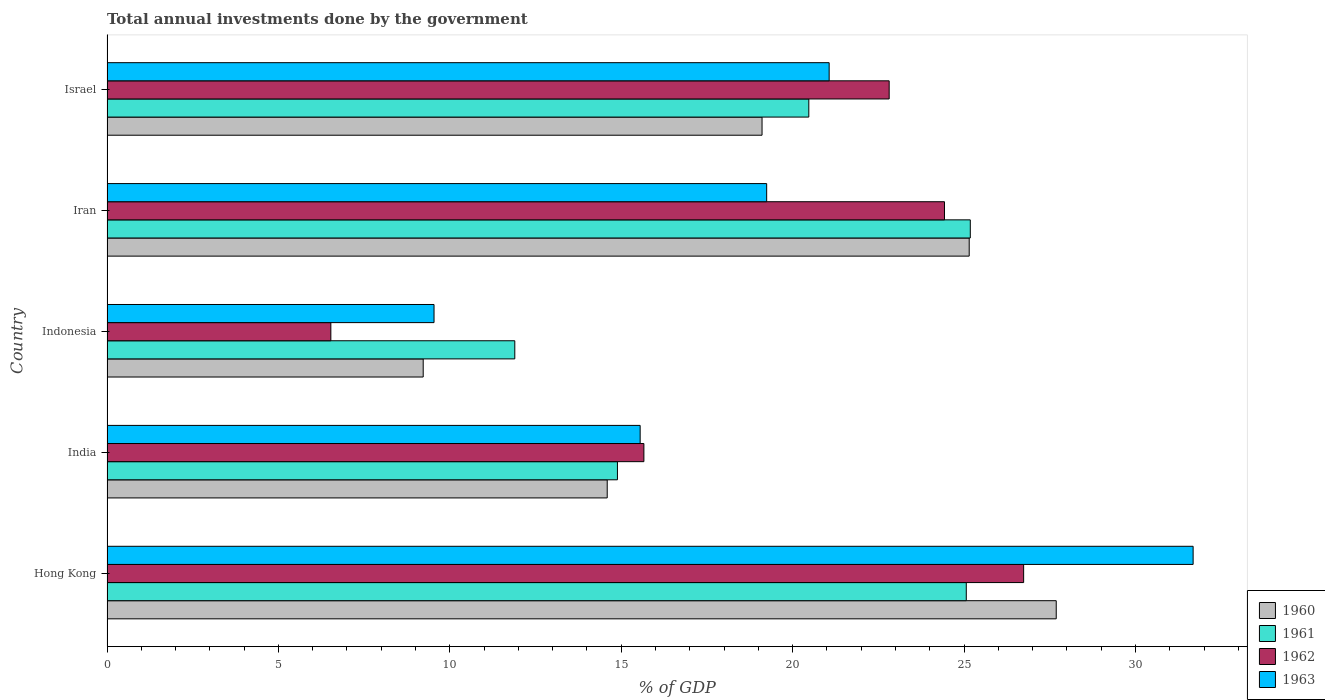How many different coloured bars are there?
Ensure brevity in your answer.  4. Are the number of bars per tick equal to the number of legend labels?
Ensure brevity in your answer.  Yes. How many bars are there on the 1st tick from the top?
Provide a short and direct response. 4. What is the label of the 1st group of bars from the top?
Offer a very short reply. Israel. What is the total annual investments done by the government in 1960 in India?
Offer a very short reply. 14.59. Across all countries, what is the maximum total annual investments done by the government in 1961?
Ensure brevity in your answer.  25.18. Across all countries, what is the minimum total annual investments done by the government in 1963?
Offer a very short reply. 9.54. In which country was the total annual investments done by the government in 1962 maximum?
Give a very brief answer. Hong Kong. What is the total total annual investments done by the government in 1960 in the graph?
Keep it short and to the point. 95.76. What is the difference between the total annual investments done by the government in 1963 in Indonesia and that in Iran?
Make the answer very short. -9.7. What is the difference between the total annual investments done by the government in 1960 in India and the total annual investments done by the government in 1963 in Iran?
Offer a very short reply. -4.65. What is the average total annual investments done by the government in 1960 per country?
Ensure brevity in your answer.  19.15. What is the difference between the total annual investments done by the government in 1962 and total annual investments done by the government in 1960 in India?
Give a very brief answer. 1.07. What is the ratio of the total annual investments done by the government in 1963 in Hong Kong to that in Iran?
Offer a terse response. 1.65. Is the total annual investments done by the government in 1961 in India less than that in Indonesia?
Provide a succinct answer. No. What is the difference between the highest and the second highest total annual investments done by the government in 1963?
Offer a terse response. 10.62. What is the difference between the highest and the lowest total annual investments done by the government in 1963?
Offer a very short reply. 22.14. In how many countries, is the total annual investments done by the government in 1960 greater than the average total annual investments done by the government in 1960 taken over all countries?
Ensure brevity in your answer.  2. Is it the case that in every country, the sum of the total annual investments done by the government in 1963 and total annual investments done by the government in 1960 is greater than the sum of total annual investments done by the government in 1961 and total annual investments done by the government in 1962?
Offer a very short reply. No. What does the 1st bar from the top in Indonesia represents?
Offer a terse response. 1963. What does the 2nd bar from the bottom in Indonesia represents?
Offer a very short reply. 1961. Is it the case that in every country, the sum of the total annual investments done by the government in 1960 and total annual investments done by the government in 1963 is greater than the total annual investments done by the government in 1962?
Keep it short and to the point. Yes. How many countries are there in the graph?
Ensure brevity in your answer.  5. What is the difference between two consecutive major ticks on the X-axis?
Provide a succinct answer. 5. Does the graph contain any zero values?
Give a very brief answer. No. Where does the legend appear in the graph?
Give a very brief answer. Bottom right. How are the legend labels stacked?
Ensure brevity in your answer.  Vertical. What is the title of the graph?
Your answer should be compact. Total annual investments done by the government. Does "2005" appear as one of the legend labels in the graph?
Offer a very short reply. No. What is the label or title of the X-axis?
Keep it short and to the point. % of GDP. What is the label or title of the Y-axis?
Make the answer very short. Country. What is the % of GDP of 1960 in Hong Kong?
Your answer should be compact. 27.69. What is the % of GDP in 1961 in Hong Kong?
Give a very brief answer. 25.06. What is the % of GDP in 1962 in Hong Kong?
Make the answer very short. 26.74. What is the % of GDP of 1963 in Hong Kong?
Your response must be concise. 31.68. What is the % of GDP of 1960 in India?
Offer a very short reply. 14.59. What is the % of GDP of 1961 in India?
Give a very brief answer. 14.89. What is the % of GDP of 1962 in India?
Keep it short and to the point. 15.66. What is the % of GDP in 1963 in India?
Make the answer very short. 15.55. What is the % of GDP of 1960 in Indonesia?
Provide a short and direct response. 9.22. What is the % of GDP in 1961 in Indonesia?
Ensure brevity in your answer.  11.9. What is the % of GDP in 1962 in Indonesia?
Keep it short and to the point. 6.53. What is the % of GDP of 1963 in Indonesia?
Provide a short and direct response. 9.54. What is the % of GDP in 1960 in Iran?
Your response must be concise. 25.15. What is the % of GDP of 1961 in Iran?
Provide a short and direct response. 25.18. What is the % of GDP of 1962 in Iran?
Provide a succinct answer. 24.43. What is the % of GDP in 1963 in Iran?
Offer a terse response. 19.24. What is the % of GDP in 1960 in Israel?
Keep it short and to the point. 19.11. What is the % of GDP in 1961 in Israel?
Give a very brief answer. 20.47. What is the % of GDP in 1962 in Israel?
Ensure brevity in your answer.  22.82. What is the % of GDP in 1963 in Israel?
Ensure brevity in your answer.  21.06. Across all countries, what is the maximum % of GDP of 1960?
Provide a succinct answer. 27.69. Across all countries, what is the maximum % of GDP in 1961?
Ensure brevity in your answer.  25.18. Across all countries, what is the maximum % of GDP of 1962?
Your response must be concise. 26.74. Across all countries, what is the maximum % of GDP in 1963?
Provide a succinct answer. 31.68. Across all countries, what is the minimum % of GDP in 1960?
Provide a short and direct response. 9.22. Across all countries, what is the minimum % of GDP in 1961?
Your answer should be very brief. 11.9. Across all countries, what is the minimum % of GDP in 1962?
Ensure brevity in your answer.  6.53. Across all countries, what is the minimum % of GDP in 1963?
Your response must be concise. 9.54. What is the total % of GDP of 1960 in the graph?
Offer a terse response. 95.76. What is the total % of GDP in 1961 in the graph?
Provide a short and direct response. 97.5. What is the total % of GDP in 1962 in the graph?
Ensure brevity in your answer.  96.17. What is the total % of GDP in 1963 in the graph?
Offer a terse response. 97.08. What is the difference between the % of GDP of 1960 in Hong Kong and that in India?
Make the answer very short. 13.1. What is the difference between the % of GDP of 1961 in Hong Kong and that in India?
Your response must be concise. 10.18. What is the difference between the % of GDP of 1962 in Hong Kong and that in India?
Your response must be concise. 11.08. What is the difference between the % of GDP of 1963 in Hong Kong and that in India?
Your answer should be very brief. 16.13. What is the difference between the % of GDP of 1960 in Hong Kong and that in Indonesia?
Give a very brief answer. 18.47. What is the difference between the % of GDP in 1961 in Hong Kong and that in Indonesia?
Your response must be concise. 13.17. What is the difference between the % of GDP of 1962 in Hong Kong and that in Indonesia?
Offer a very short reply. 20.21. What is the difference between the % of GDP of 1963 in Hong Kong and that in Indonesia?
Your answer should be very brief. 22.14. What is the difference between the % of GDP in 1960 in Hong Kong and that in Iran?
Offer a very short reply. 2.54. What is the difference between the % of GDP in 1961 in Hong Kong and that in Iran?
Keep it short and to the point. -0.12. What is the difference between the % of GDP in 1962 in Hong Kong and that in Iran?
Keep it short and to the point. 2.31. What is the difference between the % of GDP in 1963 in Hong Kong and that in Iran?
Your answer should be very brief. 12.44. What is the difference between the % of GDP in 1960 in Hong Kong and that in Israel?
Provide a succinct answer. 8.58. What is the difference between the % of GDP in 1961 in Hong Kong and that in Israel?
Keep it short and to the point. 4.59. What is the difference between the % of GDP in 1962 in Hong Kong and that in Israel?
Provide a short and direct response. 3.92. What is the difference between the % of GDP of 1963 in Hong Kong and that in Israel?
Offer a terse response. 10.62. What is the difference between the % of GDP of 1960 in India and that in Indonesia?
Your answer should be very brief. 5.37. What is the difference between the % of GDP in 1961 in India and that in Indonesia?
Keep it short and to the point. 2.99. What is the difference between the % of GDP of 1962 in India and that in Indonesia?
Provide a short and direct response. 9.13. What is the difference between the % of GDP in 1963 in India and that in Indonesia?
Offer a very short reply. 6.01. What is the difference between the % of GDP in 1960 in India and that in Iran?
Your answer should be compact. -10.56. What is the difference between the % of GDP of 1961 in India and that in Iran?
Provide a short and direct response. -10.29. What is the difference between the % of GDP of 1962 in India and that in Iran?
Provide a short and direct response. -8.77. What is the difference between the % of GDP in 1963 in India and that in Iran?
Provide a short and direct response. -3.69. What is the difference between the % of GDP in 1960 in India and that in Israel?
Make the answer very short. -4.52. What is the difference between the % of GDP in 1961 in India and that in Israel?
Ensure brevity in your answer.  -5.58. What is the difference between the % of GDP in 1962 in India and that in Israel?
Offer a very short reply. -7.15. What is the difference between the % of GDP in 1963 in India and that in Israel?
Give a very brief answer. -5.51. What is the difference between the % of GDP in 1960 in Indonesia and that in Iran?
Provide a succinct answer. -15.93. What is the difference between the % of GDP in 1961 in Indonesia and that in Iran?
Make the answer very short. -13.29. What is the difference between the % of GDP of 1962 in Indonesia and that in Iran?
Make the answer very short. -17.9. What is the difference between the % of GDP of 1963 in Indonesia and that in Iran?
Your answer should be compact. -9.7. What is the difference between the % of GDP in 1960 in Indonesia and that in Israel?
Provide a short and direct response. -9.88. What is the difference between the % of GDP of 1961 in Indonesia and that in Israel?
Your answer should be compact. -8.58. What is the difference between the % of GDP in 1962 in Indonesia and that in Israel?
Make the answer very short. -16.29. What is the difference between the % of GDP of 1963 in Indonesia and that in Israel?
Offer a terse response. -11.53. What is the difference between the % of GDP in 1960 in Iran and that in Israel?
Your response must be concise. 6.04. What is the difference between the % of GDP in 1961 in Iran and that in Israel?
Give a very brief answer. 4.71. What is the difference between the % of GDP in 1962 in Iran and that in Israel?
Keep it short and to the point. 1.61. What is the difference between the % of GDP of 1963 in Iran and that in Israel?
Give a very brief answer. -1.82. What is the difference between the % of GDP of 1960 in Hong Kong and the % of GDP of 1961 in India?
Ensure brevity in your answer.  12.8. What is the difference between the % of GDP in 1960 in Hong Kong and the % of GDP in 1962 in India?
Give a very brief answer. 12.03. What is the difference between the % of GDP in 1960 in Hong Kong and the % of GDP in 1963 in India?
Keep it short and to the point. 12.14. What is the difference between the % of GDP in 1961 in Hong Kong and the % of GDP in 1962 in India?
Keep it short and to the point. 9.4. What is the difference between the % of GDP of 1961 in Hong Kong and the % of GDP of 1963 in India?
Give a very brief answer. 9.51. What is the difference between the % of GDP in 1962 in Hong Kong and the % of GDP in 1963 in India?
Provide a short and direct response. 11.19. What is the difference between the % of GDP of 1960 in Hong Kong and the % of GDP of 1961 in Indonesia?
Keep it short and to the point. 15.79. What is the difference between the % of GDP in 1960 in Hong Kong and the % of GDP in 1962 in Indonesia?
Give a very brief answer. 21.16. What is the difference between the % of GDP in 1960 in Hong Kong and the % of GDP in 1963 in Indonesia?
Make the answer very short. 18.15. What is the difference between the % of GDP of 1961 in Hong Kong and the % of GDP of 1962 in Indonesia?
Offer a very short reply. 18.54. What is the difference between the % of GDP of 1961 in Hong Kong and the % of GDP of 1963 in Indonesia?
Offer a terse response. 15.53. What is the difference between the % of GDP in 1962 in Hong Kong and the % of GDP in 1963 in Indonesia?
Offer a very short reply. 17.2. What is the difference between the % of GDP of 1960 in Hong Kong and the % of GDP of 1961 in Iran?
Keep it short and to the point. 2.51. What is the difference between the % of GDP of 1960 in Hong Kong and the % of GDP of 1962 in Iran?
Give a very brief answer. 3.26. What is the difference between the % of GDP of 1960 in Hong Kong and the % of GDP of 1963 in Iran?
Make the answer very short. 8.45. What is the difference between the % of GDP of 1961 in Hong Kong and the % of GDP of 1962 in Iran?
Ensure brevity in your answer.  0.64. What is the difference between the % of GDP of 1961 in Hong Kong and the % of GDP of 1963 in Iran?
Ensure brevity in your answer.  5.82. What is the difference between the % of GDP of 1962 in Hong Kong and the % of GDP of 1963 in Iran?
Ensure brevity in your answer.  7.5. What is the difference between the % of GDP in 1960 in Hong Kong and the % of GDP in 1961 in Israel?
Ensure brevity in your answer.  7.22. What is the difference between the % of GDP of 1960 in Hong Kong and the % of GDP of 1962 in Israel?
Offer a very short reply. 4.87. What is the difference between the % of GDP in 1960 in Hong Kong and the % of GDP in 1963 in Israel?
Keep it short and to the point. 6.62. What is the difference between the % of GDP in 1961 in Hong Kong and the % of GDP in 1962 in Israel?
Keep it short and to the point. 2.25. What is the difference between the % of GDP in 1961 in Hong Kong and the % of GDP in 1963 in Israel?
Provide a short and direct response. 4. What is the difference between the % of GDP in 1962 in Hong Kong and the % of GDP in 1963 in Israel?
Make the answer very short. 5.67. What is the difference between the % of GDP in 1960 in India and the % of GDP in 1961 in Indonesia?
Offer a terse response. 2.7. What is the difference between the % of GDP in 1960 in India and the % of GDP in 1962 in Indonesia?
Provide a short and direct response. 8.06. What is the difference between the % of GDP in 1960 in India and the % of GDP in 1963 in Indonesia?
Give a very brief answer. 5.05. What is the difference between the % of GDP of 1961 in India and the % of GDP of 1962 in Indonesia?
Ensure brevity in your answer.  8.36. What is the difference between the % of GDP of 1961 in India and the % of GDP of 1963 in Indonesia?
Provide a short and direct response. 5.35. What is the difference between the % of GDP in 1962 in India and the % of GDP in 1963 in Indonesia?
Ensure brevity in your answer.  6.12. What is the difference between the % of GDP in 1960 in India and the % of GDP in 1961 in Iran?
Offer a terse response. -10.59. What is the difference between the % of GDP in 1960 in India and the % of GDP in 1962 in Iran?
Provide a short and direct response. -9.84. What is the difference between the % of GDP of 1960 in India and the % of GDP of 1963 in Iran?
Make the answer very short. -4.65. What is the difference between the % of GDP in 1961 in India and the % of GDP in 1962 in Iran?
Offer a very short reply. -9.54. What is the difference between the % of GDP in 1961 in India and the % of GDP in 1963 in Iran?
Offer a terse response. -4.35. What is the difference between the % of GDP of 1962 in India and the % of GDP of 1963 in Iran?
Keep it short and to the point. -3.58. What is the difference between the % of GDP in 1960 in India and the % of GDP in 1961 in Israel?
Your answer should be very brief. -5.88. What is the difference between the % of GDP in 1960 in India and the % of GDP in 1962 in Israel?
Make the answer very short. -8.22. What is the difference between the % of GDP in 1960 in India and the % of GDP in 1963 in Israel?
Your response must be concise. -6.47. What is the difference between the % of GDP in 1961 in India and the % of GDP in 1962 in Israel?
Provide a succinct answer. -7.93. What is the difference between the % of GDP in 1961 in India and the % of GDP in 1963 in Israel?
Keep it short and to the point. -6.18. What is the difference between the % of GDP of 1962 in India and the % of GDP of 1963 in Israel?
Provide a short and direct response. -5.4. What is the difference between the % of GDP in 1960 in Indonesia and the % of GDP in 1961 in Iran?
Offer a terse response. -15.96. What is the difference between the % of GDP in 1960 in Indonesia and the % of GDP in 1962 in Iran?
Ensure brevity in your answer.  -15.21. What is the difference between the % of GDP in 1960 in Indonesia and the % of GDP in 1963 in Iran?
Provide a short and direct response. -10.02. What is the difference between the % of GDP of 1961 in Indonesia and the % of GDP of 1962 in Iran?
Ensure brevity in your answer.  -12.53. What is the difference between the % of GDP in 1961 in Indonesia and the % of GDP in 1963 in Iran?
Your answer should be very brief. -7.35. What is the difference between the % of GDP in 1962 in Indonesia and the % of GDP in 1963 in Iran?
Provide a succinct answer. -12.71. What is the difference between the % of GDP of 1960 in Indonesia and the % of GDP of 1961 in Israel?
Make the answer very short. -11.25. What is the difference between the % of GDP in 1960 in Indonesia and the % of GDP in 1962 in Israel?
Offer a terse response. -13.59. What is the difference between the % of GDP in 1960 in Indonesia and the % of GDP in 1963 in Israel?
Your answer should be very brief. -11.84. What is the difference between the % of GDP in 1961 in Indonesia and the % of GDP in 1962 in Israel?
Your answer should be compact. -10.92. What is the difference between the % of GDP of 1961 in Indonesia and the % of GDP of 1963 in Israel?
Provide a short and direct response. -9.17. What is the difference between the % of GDP in 1962 in Indonesia and the % of GDP in 1963 in Israel?
Your answer should be very brief. -14.54. What is the difference between the % of GDP in 1960 in Iran and the % of GDP in 1961 in Israel?
Your answer should be compact. 4.68. What is the difference between the % of GDP of 1960 in Iran and the % of GDP of 1962 in Israel?
Keep it short and to the point. 2.33. What is the difference between the % of GDP in 1960 in Iran and the % of GDP in 1963 in Israel?
Offer a terse response. 4.08. What is the difference between the % of GDP in 1961 in Iran and the % of GDP in 1962 in Israel?
Your answer should be very brief. 2.37. What is the difference between the % of GDP of 1961 in Iran and the % of GDP of 1963 in Israel?
Ensure brevity in your answer.  4.12. What is the difference between the % of GDP of 1962 in Iran and the % of GDP of 1963 in Israel?
Provide a short and direct response. 3.36. What is the average % of GDP in 1960 per country?
Your answer should be compact. 19.15. What is the average % of GDP in 1961 per country?
Your answer should be compact. 19.5. What is the average % of GDP in 1962 per country?
Provide a succinct answer. 19.23. What is the average % of GDP in 1963 per country?
Keep it short and to the point. 19.42. What is the difference between the % of GDP of 1960 and % of GDP of 1961 in Hong Kong?
Your response must be concise. 2.62. What is the difference between the % of GDP in 1960 and % of GDP in 1962 in Hong Kong?
Keep it short and to the point. 0.95. What is the difference between the % of GDP of 1960 and % of GDP of 1963 in Hong Kong?
Keep it short and to the point. -3.99. What is the difference between the % of GDP of 1961 and % of GDP of 1962 in Hong Kong?
Your answer should be compact. -1.67. What is the difference between the % of GDP in 1961 and % of GDP in 1963 in Hong Kong?
Offer a terse response. -6.62. What is the difference between the % of GDP of 1962 and % of GDP of 1963 in Hong Kong?
Offer a very short reply. -4.94. What is the difference between the % of GDP in 1960 and % of GDP in 1961 in India?
Your response must be concise. -0.3. What is the difference between the % of GDP in 1960 and % of GDP in 1962 in India?
Make the answer very short. -1.07. What is the difference between the % of GDP in 1960 and % of GDP in 1963 in India?
Ensure brevity in your answer.  -0.96. What is the difference between the % of GDP in 1961 and % of GDP in 1962 in India?
Your answer should be compact. -0.77. What is the difference between the % of GDP in 1961 and % of GDP in 1963 in India?
Offer a terse response. -0.66. What is the difference between the % of GDP of 1962 and % of GDP of 1963 in India?
Your response must be concise. 0.11. What is the difference between the % of GDP of 1960 and % of GDP of 1961 in Indonesia?
Make the answer very short. -2.67. What is the difference between the % of GDP in 1960 and % of GDP in 1962 in Indonesia?
Give a very brief answer. 2.69. What is the difference between the % of GDP in 1960 and % of GDP in 1963 in Indonesia?
Ensure brevity in your answer.  -0.32. What is the difference between the % of GDP of 1961 and % of GDP of 1962 in Indonesia?
Offer a very short reply. 5.37. What is the difference between the % of GDP in 1961 and % of GDP in 1963 in Indonesia?
Offer a terse response. 2.36. What is the difference between the % of GDP in 1962 and % of GDP in 1963 in Indonesia?
Give a very brief answer. -3.01. What is the difference between the % of GDP of 1960 and % of GDP of 1961 in Iran?
Keep it short and to the point. -0.03. What is the difference between the % of GDP of 1960 and % of GDP of 1962 in Iran?
Give a very brief answer. 0.72. What is the difference between the % of GDP of 1960 and % of GDP of 1963 in Iran?
Ensure brevity in your answer.  5.91. What is the difference between the % of GDP in 1961 and % of GDP in 1962 in Iran?
Offer a very short reply. 0.75. What is the difference between the % of GDP of 1961 and % of GDP of 1963 in Iran?
Make the answer very short. 5.94. What is the difference between the % of GDP of 1962 and % of GDP of 1963 in Iran?
Your answer should be very brief. 5.19. What is the difference between the % of GDP in 1960 and % of GDP in 1961 in Israel?
Ensure brevity in your answer.  -1.36. What is the difference between the % of GDP in 1960 and % of GDP in 1962 in Israel?
Your answer should be very brief. -3.71. What is the difference between the % of GDP of 1960 and % of GDP of 1963 in Israel?
Make the answer very short. -1.96. What is the difference between the % of GDP of 1961 and % of GDP of 1962 in Israel?
Ensure brevity in your answer.  -2.34. What is the difference between the % of GDP of 1961 and % of GDP of 1963 in Israel?
Keep it short and to the point. -0.59. What is the difference between the % of GDP in 1962 and % of GDP in 1963 in Israel?
Give a very brief answer. 1.75. What is the ratio of the % of GDP of 1960 in Hong Kong to that in India?
Your response must be concise. 1.9. What is the ratio of the % of GDP of 1961 in Hong Kong to that in India?
Your response must be concise. 1.68. What is the ratio of the % of GDP in 1962 in Hong Kong to that in India?
Offer a terse response. 1.71. What is the ratio of the % of GDP of 1963 in Hong Kong to that in India?
Offer a very short reply. 2.04. What is the ratio of the % of GDP in 1960 in Hong Kong to that in Indonesia?
Offer a terse response. 3. What is the ratio of the % of GDP in 1961 in Hong Kong to that in Indonesia?
Give a very brief answer. 2.11. What is the ratio of the % of GDP in 1962 in Hong Kong to that in Indonesia?
Make the answer very short. 4.09. What is the ratio of the % of GDP in 1963 in Hong Kong to that in Indonesia?
Offer a very short reply. 3.32. What is the ratio of the % of GDP in 1960 in Hong Kong to that in Iran?
Your answer should be compact. 1.1. What is the ratio of the % of GDP in 1961 in Hong Kong to that in Iran?
Make the answer very short. 1. What is the ratio of the % of GDP in 1962 in Hong Kong to that in Iran?
Provide a succinct answer. 1.09. What is the ratio of the % of GDP of 1963 in Hong Kong to that in Iran?
Keep it short and to the point. 1.65. What is the ratio of the % of GDP of 1960 in Hong Kong to that in Israel?
Provide a short and direct response. 1.45. What is the ratio of the % of GDP of 1961 in Hong Kong to that in Israel?
Give a very brief answer. 1.22. What is the ratio of the % of GDP in 1962 in Hong Kong to that in Israel?
Your answer should be compact. 1.17. What is the ratio of the % of GDP in 1963 in Hong Kong to that in Israel?
Ensure brevity in your answer.  1.5. What is the ratio of the % of GDP of 1960 in India to that in Indonesia?
Provide a short and direct response. 1.58. What is the ratio of the % of GDP in 1961 in India to that in Indonesia?
Keep it short and to the point. 1.25. What is the ratio of the % of GDP of 1962 in India to that in Indonesia?
Provide a succinct answer. 2.4. What is the ratio of the % of GDP in 1963 in India to that in Indonesia?
Provide a succinct answer. 1.63. What is the ratio of the % of GDP in 1960 in India to that in Iran?
Your answer should be very brief. 0.58. What is the ratio of the % of GDP of 1961 in India to that in Iran?
Your answer should be compact. 0.59. What is the ratio of the % of GDP of 1962 in India to that in Iran?
Provide a succinct answer. 0.64. What is the ratio of the % of GDP in 1963 in India to that in Iran?
Offer a very short reply. 0.81. What is the ratio of the % of GDP in 1960 in India to that in Israel?
Ensure brevity in your answer.  0.76. What is the ratio of the % of GDP in 1961 in India to that in Israel?
Your answer should be very brief. 0.73. What is the ratio of the % of GDP of 1962 in India to that in Israel?
Your answer should be very brief. 0.69. What is the ratio of the % of GDP of 1963 in India to that in Israel?
Offer a very short reply. 0.74. What is the ratio of the % of GDP in 1960 in Indonesia to that in Iran?
Provide a short and direct response. 0.37. What is the ratio of the % of GDP of 1961 in Indonesia to that in Iran?
Your response must be concise. 0.47. What is the ratio of the % of GDP in 1962 in Indonesia to that in Iran?
Provide a short and direct response. 0.27. What is the ratio of the % of GDP of 1963 in Indonesia to that in Iran?
Make the answer very short. 0.5. What is the ratio of the % of GDP in 1960 in Indonesia to that in Israel?
Ensure brevity in your answer.  0.48. What is the ratio of the % of GDP in 1961 in Indonesia to that in Israel?
Keep it short and to the point. 0.58. What is the ratio of the % of GDP of 1962 in Indonesia to that in Israel?
Make the answer very short. 0.29. What is the ratio of the % of GDP of 1963 in Indonesia to that in Israel?
Your answer should be compact. 0.45. What is the ratio of the % of GDP of 1960 in Iran to that in Israel?
Make the answer very short. 1.32. What is the ratio of the % of GDP in 1961 in Iran to that in Israel?
Offer a very short reply. 1.23. What is the ratio of the % of GDP of 1962 in Iran to that in Israel?
Ensure brevity in your answer.  1.07. What is the ratio of the % of GDP of 1963 in Iran to that in Israel?
Provide a short and direct response. 0.91. What is the difference between the highest and the second highest % of GDP of 1960?
Make the answer very short. 2.54. What is the difference between the highest and the second highest % of GDP in 1961?
Offer a terse response. 0.12. What is the difference between the highest and the second highest % of GDP of 1962?
Make the answer very short. 2.31. What is the difference between the highest and the second highest % of GDP of 1963?
Offer a very short reply. 10.62. What is the difference between the highest and the lowest % of GDP in 1960?
Your response must be concise. 18.47. What is the difference between the highest and the lowest % of GDP of 1961?
Ensure brevity in your answer.  13.29. What is the difference between the highest and the lowest % of GDP of 1962?
Give a very brief answer. 20.21. What is the difference between the highest and the lowest % of GDP in 1963?
Your response must be concise. 22.14. 